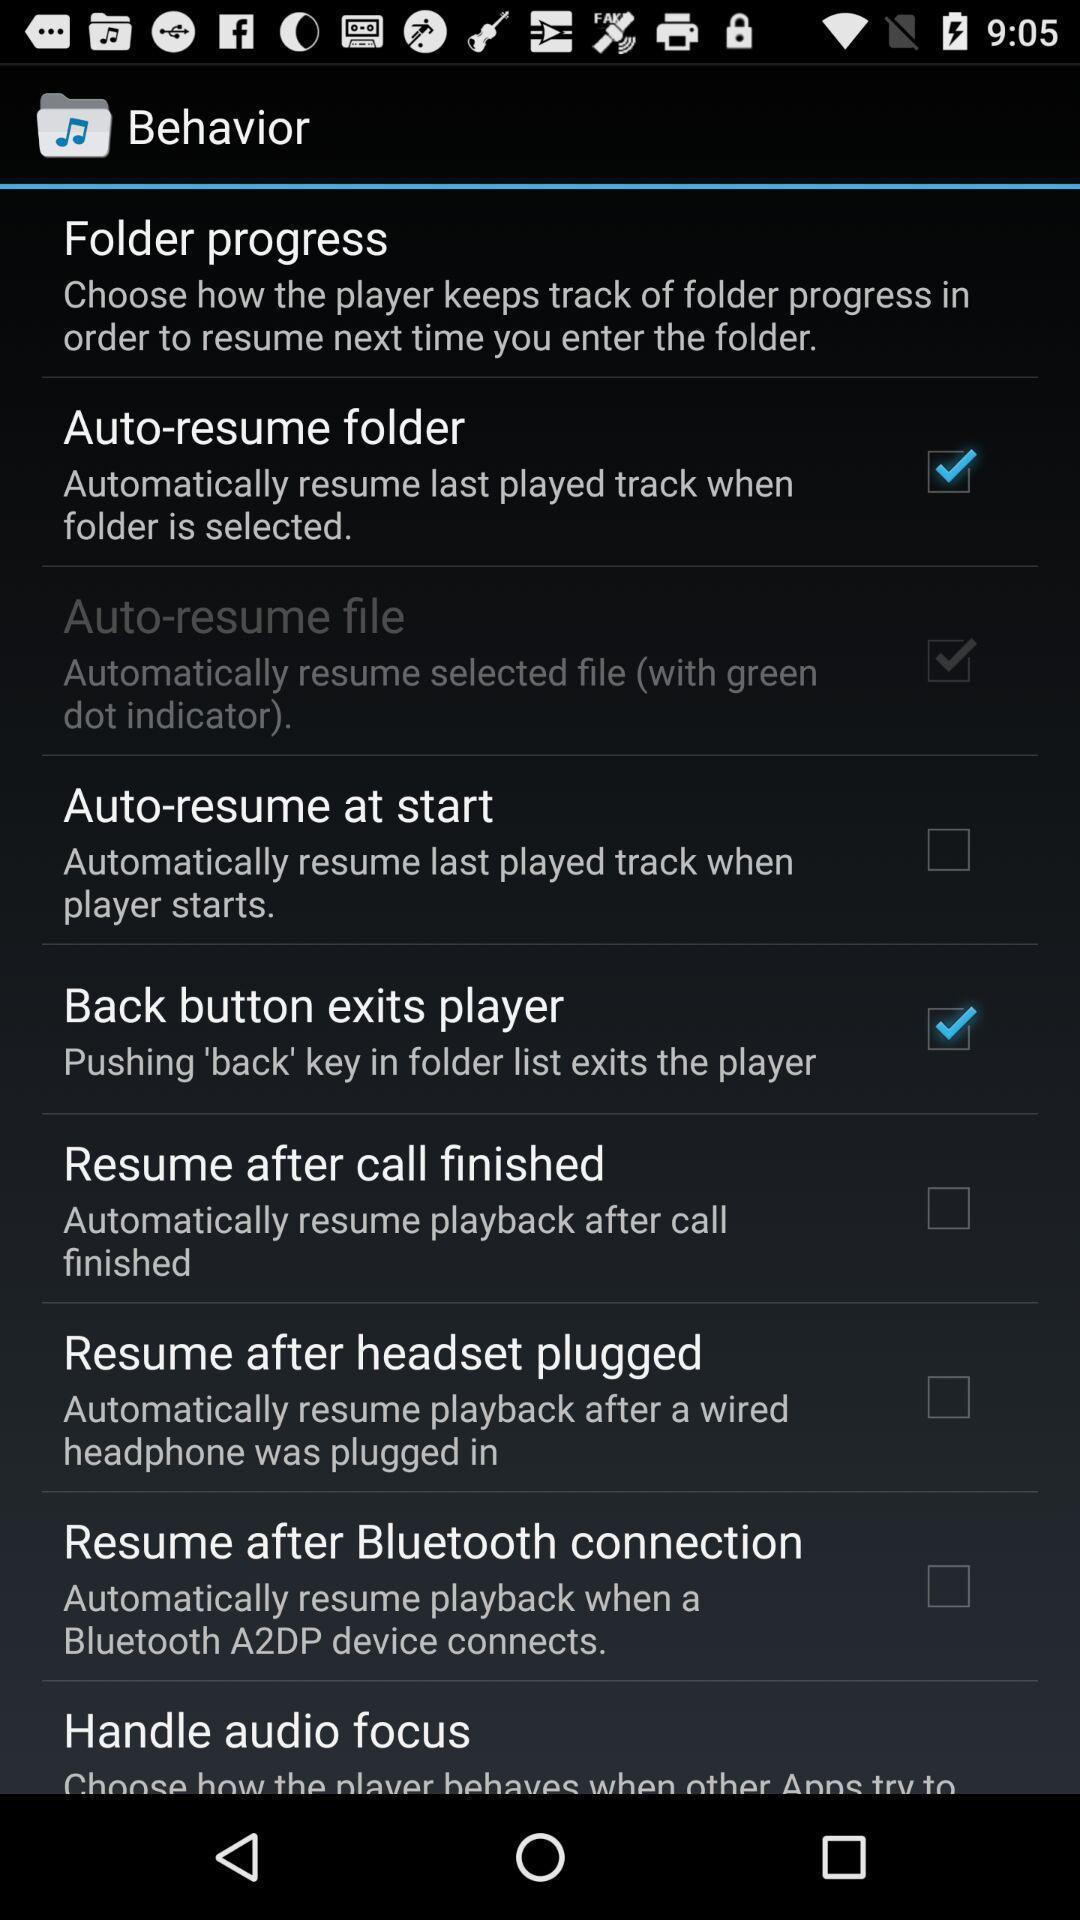Provide a description of this screenshot. Screen showing behavior options. 